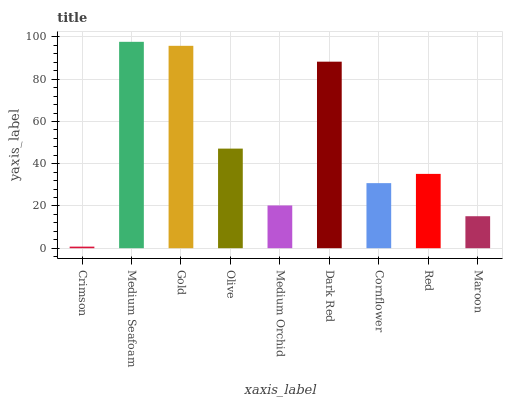Is Crimson the minimum?
Answer yes or no. Yes. Is Medium Seafoam the maximum?
Answer yes or no. Yes. Is Gold the minimum?
Answer yes or no. No. Is Gold the maximum?
Answer yes or no. No. Is Medium Seafoam greater than Gold?
Answer yes or no. Yes. Is Gold less than Medium Seafoam?
Answer yes or no. Yes. Is Gold greater than Medium Seafoam?
Answer yes or no. No. Is Medium Seafoam less than Gold?
Answer yes or no. No. Is Red the high median?
Answer yes or no. Yes. Is Red the low median?
Answer yes or no. Yes. Is Crimson the high median?
Answer yes or no. No. Is Cornflower the low median?
Answer yes or no. No. 